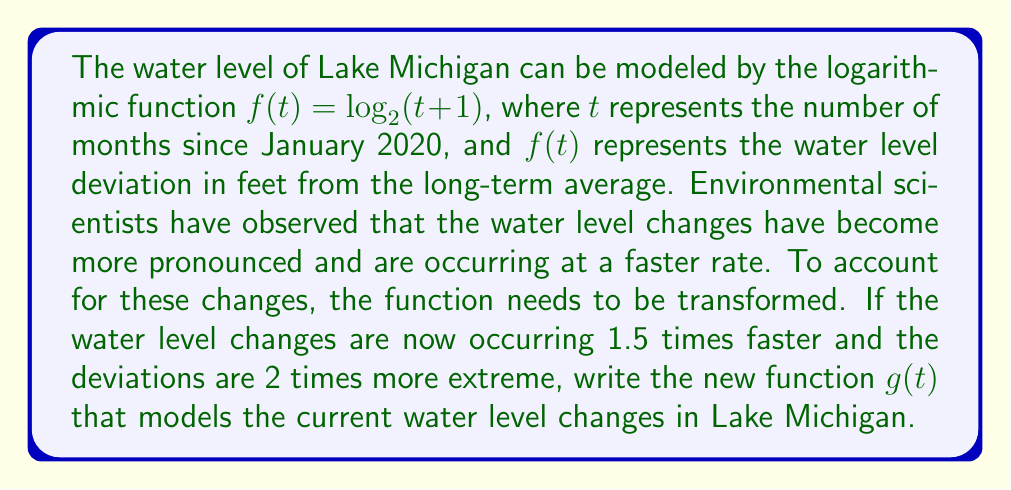Show me your answer to this math problem. To solve this problem, we need to apply both horizontal and vertical stretches to the original function. Let's break it down step-by-step:

1. The original function is $f(t) = \log_2(t+1)$

2. The water level changes are occurring 1.5 times faster. This means we need to apply a horizontal compression by a factor of 1.5. To do this, we replace $t$ with $\frac{3t}{2}$:

   $f(\frac{3t}{2}) = \log_2(\frac{3t}{2}+1)$

3. The deviations are 2 times more extreme. This means we need to apply a vertical stretch by a factor of 2. To do this, we multiply the entire function by 2:

   $2f(\frac{3t}{2}) = 2\log_2(\frac{3t}{2}+1)$

4. The new function $g(t)$ is the result of these transformations:

   $g(t) = 2\log_2(\frac{3t}{2}+1)$

This new function $g(t)$ models the current water level changes in Lake Michigan, taking into account the faster rate of change and more extreme deviations.
Answer: $g(t) = 2\log_2(\frac{3t}{2}+1)$ 